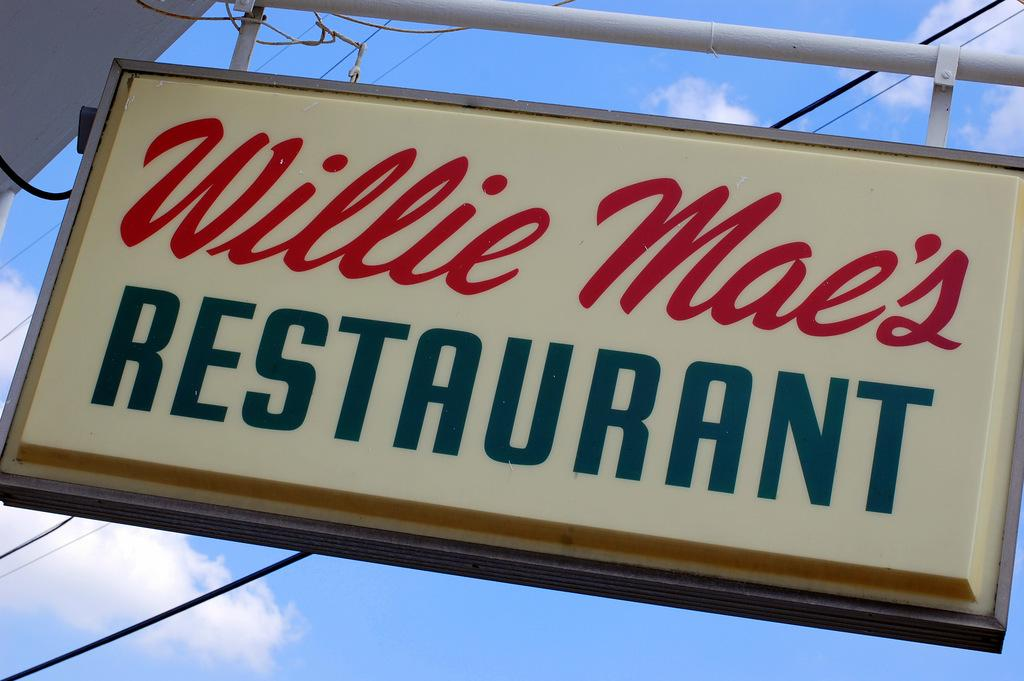Provide a one-sentence caption for the provided image. Wille Mae's Restaurant's sign is displayed high on a bright day. 